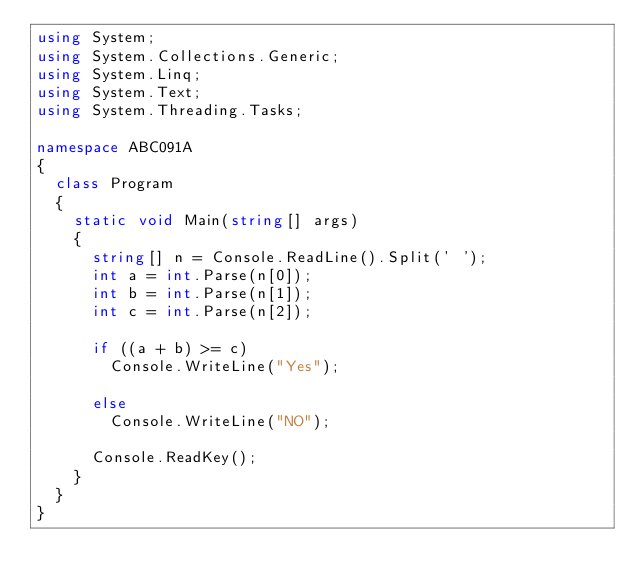<code> <loc_0><loc_0><loc_500><loc_500><_C#_>using System;
using System.Collections.Generic;
using System.Linq;
using System.Text;
using System.Threading.Tasks;

namespace ABC091A
{
	class Program
	{
		static void Main(string[] args)
		{
			string[] n = Console.ReadLine().Split(' ');
			int a = int.Parse(n[0]);
			int b = int.Parse(n[1]);
			int c = int.Parse(n[2]);

			if ((a + b) >= c)
				Console.WriteLine("Yes");

			else
				Console.WriteLine("NO");

			Console.ReadKey();
		}
	}
}</code> 